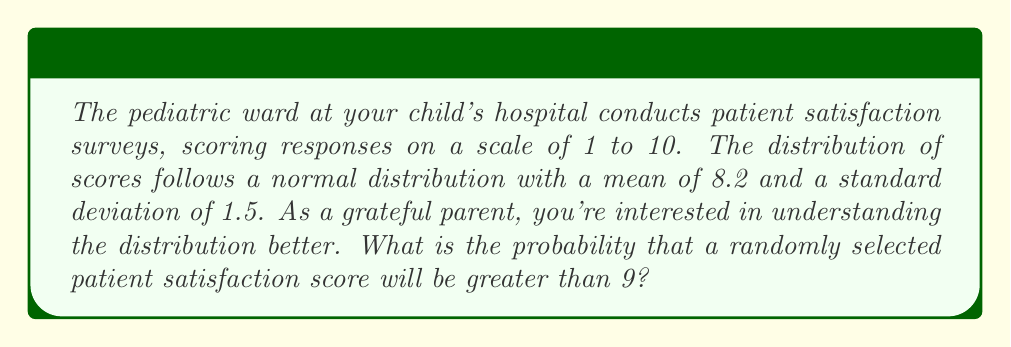Teach me how to tackle this problem. To solve this problem, we'll use the properties of the normal distribution and the z-score formula.

Step 1: Identify the given information
- The scores follow a normal distribution
- Mean (μ) = 8.2
- Standard deviation (σ) = 1.5
- We want to find P(X > 9), where X is a randomly selected score

Step 2: Calculate the z-score for X = 9
The z-score formula is: $z = \frac{X - μ}{σ}$

Substituting the values:
$z = \frac{9 - 8.2}{1.5} = \frac{0.8}{1.5} ≈ 0.5333$

Step 3: Use the standard normal distribution table or calculator
We need to find P(Z > 0.5333), where Z is the standard normal variable.

Using a standard normal table or calculator, we find:
P(Z > 0.5333) ≈ 0.2968

Step 4: Interpret the result
The probability that a randomly selected patient satisfaction score will be greater than 9 is approximately 0.2968 or 29.68%.
Answer: 0.2968 